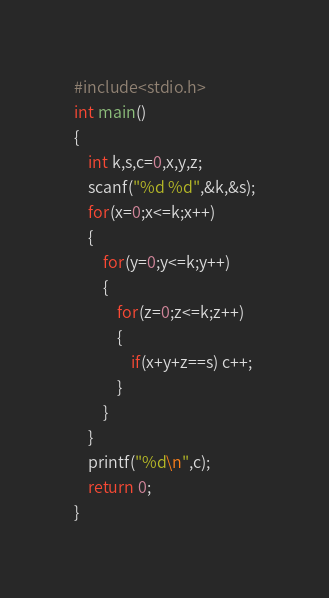<code> <loc_0><loc_0><loc_500><loc_500><_C_>#include<stdio.h>
int main()
{
    int k,s,c=0,x,y,z;
    scanf("%d %d",&k,&s);
    for(x=0;x<=k;x++)
    {
        for(y=0;y<=k;y++)
        {
            for(z=0;z<=k;z++)
            {
                if(x+y+z==s) c++;
            }
        }
    }
    printf("%d\n",c);
    return 0;
}
</code> 